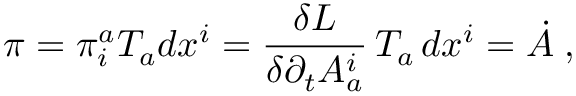Convert formula to latex. <formula><loc_0><loc_0><loc_500><loc_500>\pi = \pi _ { i } ^ { a } T _ { a } d x ^ { i } = \frac { \delta L } { \delta \partial _ { t } A _ { a } ^ { i } } \, T _ { a } \, d x ^ { i } = \dot { A } \, ,</formula> 